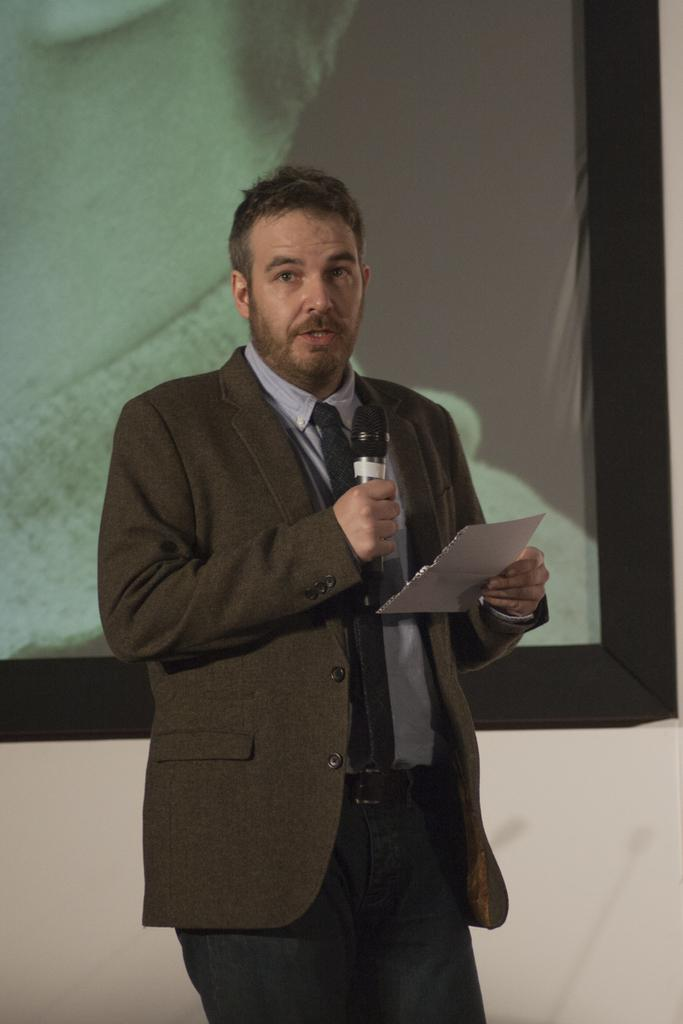What is the man in the image wearing? The man is wearing a suit, shirt, and trouser, and he is also wearing a tie. What is the man holding in the image? The man is holding a paper and a mic. What is the man doing in the image? The man is speaking. What can be seen in the background of the image? There is a screen in the background of the image. Where is the man walking in the park in the image? There is no park or man walking in the image; it features a man holding a paper and a mic while speaking. What type of pin is the man wearing on his shirt in the image? There is no pin visible on the man's shirt in the image. 